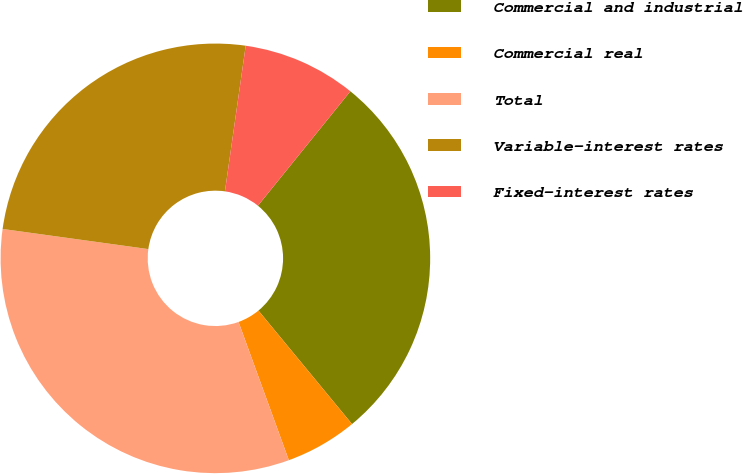Convert chart to OTSL. <chart><loc_0><loc_0><loc_500><loc_500><pie_chart><fcel>Commercial and industrial<fcel>Commercial real<fcel>Total<fcel>Variable-interest rates<fcel>Fixed-interest rates<nl><fcel>28.21%<fcel>5.42%<fcel>32.74%<fcel>25.07%<fcel>8.56%<nl></chart> 